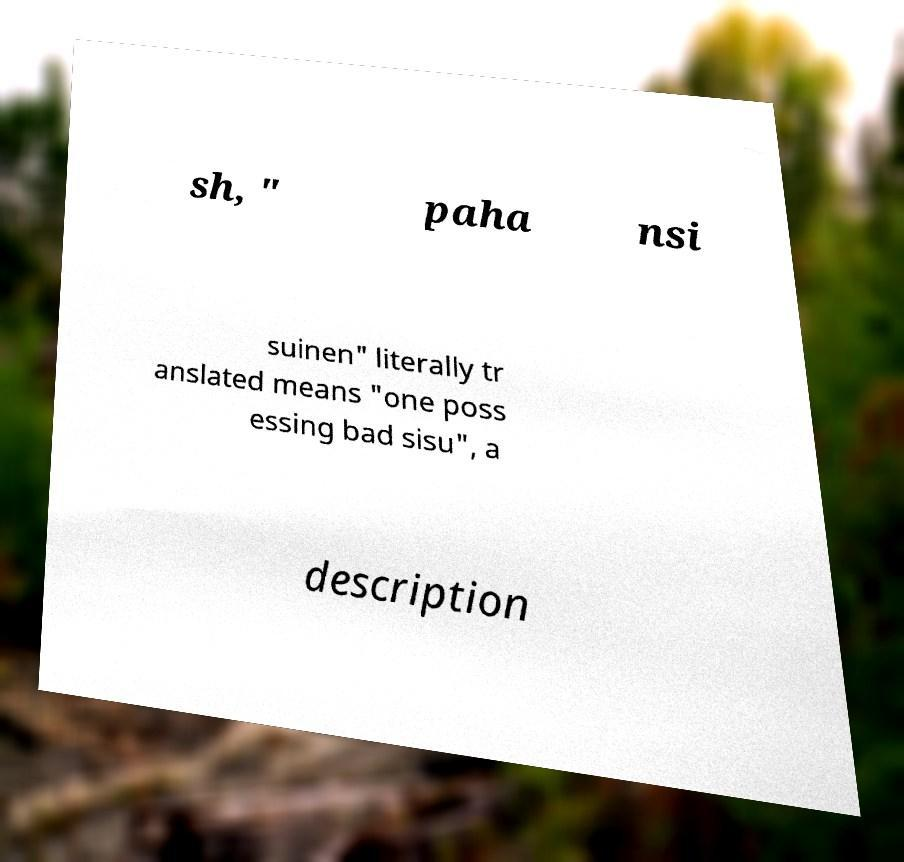For documentation purposes, I need the text within this image transcribed. Could you provide that? sh, " paha nsi suinen" literally tr anslated means "one poss essing bad sisu", a description 